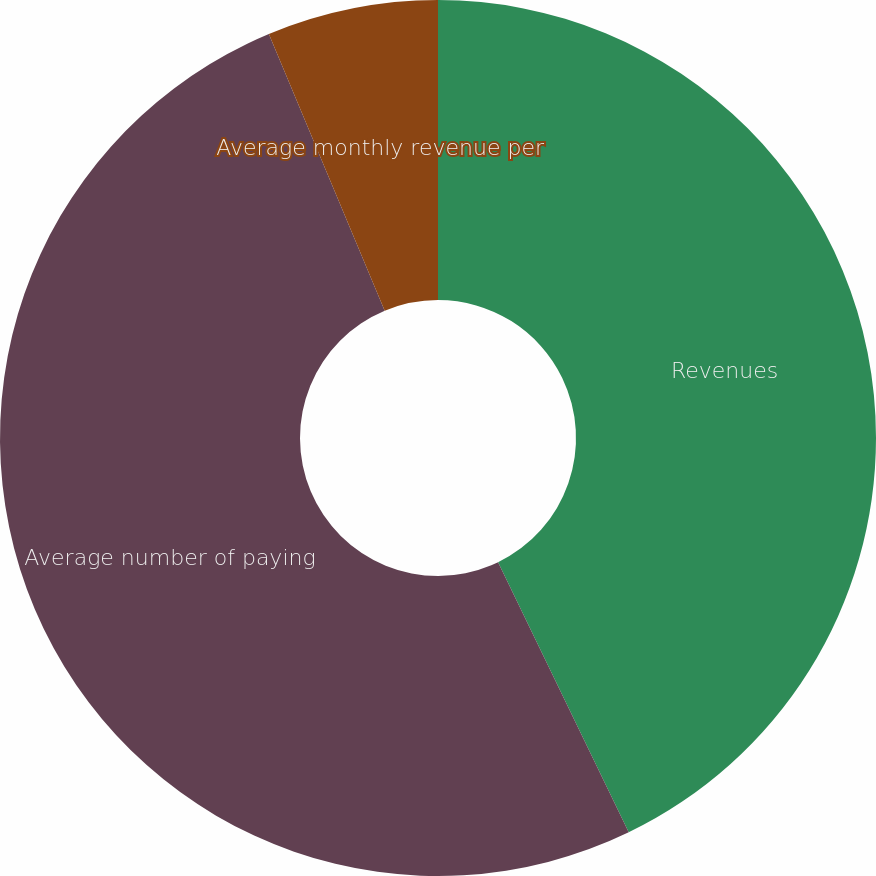<chart> <loc_0><loc_0><loc_500><loc_500><pie_chart><fcel>Revenues<fcel>Average number of paying<fcel>Average monthly revenue per<nl><fcel>42.83%<fcel>50.86%<fcel>6.31%<nl></chart> 